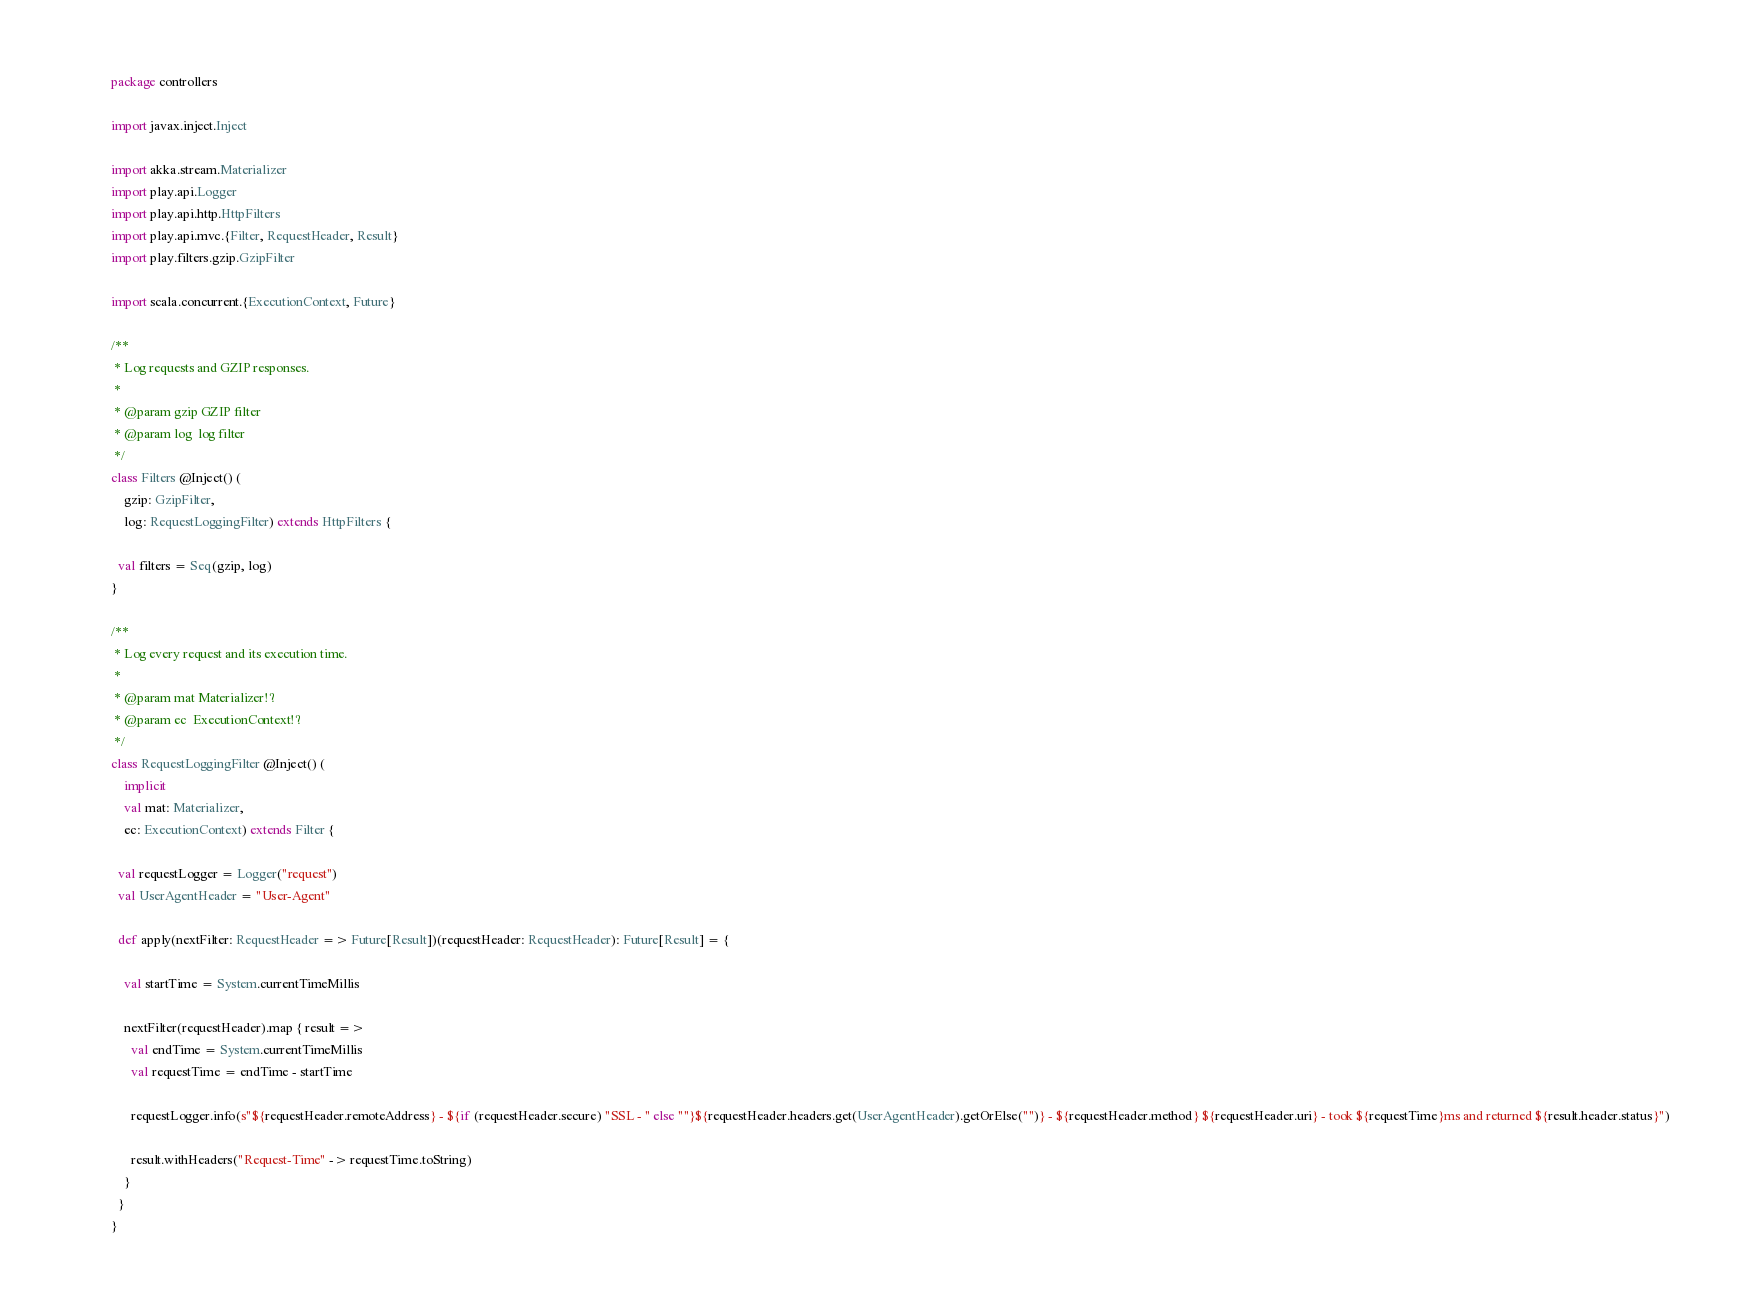<code> <loc_0><loc_0><loc_500><loc_500><_Scala_>package controllers

import javax.inject.Inject

import akka.stream.Materializer
import play.api.Logger
import play.api.http.HttpFilters
import play.api.mvc.{Filter, RequestHeader, Result}
import play.filters.gzip.GzipFilter

import scala.concurrent.{ExecutionContext, Future}

/**
 * Log requests and GZIP responses.
 *
 * @param gzip GZIP filter
 * @param log  log filter
 */
class Filters @Inject() (
    gzip: GzipFilter,
    log: RequestLoggingFilter) extends HttpFilters {

  val filters = Seq(gzip, log)
}

/**
 * Log every request and its execution time.
 *
 * @param mat Materializer!?
 * @param ec  ExecutionContext!?
 */
class RequestLoggingFilter @Inject() (
    implicit
    val mat: Materializer,
    ec: ExecutionContext) extends Filter {

  val requestLogger = Logger("request")
  val UserAgentHeader = "User-Agent"

  def apply(nextFilter: RequestHeader => Future[Result])(requestHeader: RequestHeader): Future[Result] = {

    val startTime = System.currentTimeMillis

    nextFilter(requestHeader).map { result =>
      val endTime = System.currentTimeMillis
      val requestTime = endTime - startTime

      requestLogger.info(s"${requestHeader.remoteAddress} - ${if (requestHeader.secure) "SSL - " else ""}${requestHeader.headers.get(UserAgentHeader).getOrElse("")} - ${requestHeader.method} ${requestHeader.uri} - took ${requestTime}ms and returned ${result.header.status}")

      result.withHeaders("Request-Time" -> requestTime.toString)
    }
  }
}</code> 